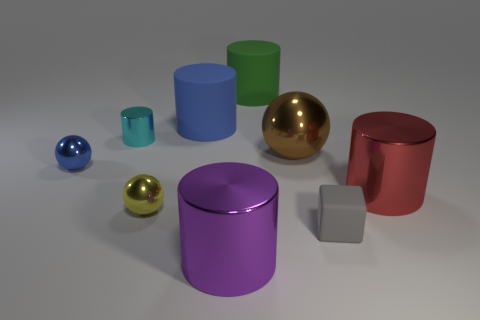Are there any purple cylinders that have the same size as the green object?
Provide a short and direct response. Yes. There is a sphere that is behind the small blue sphere; what size is it?
Your answer should be very brief. Large. There is a tiny object on the right side of the yellow shiny thing; are there any brown things that are behind it?
Your response must be concise. Yes. What number of other objects are there of the same shape as the purple object?
Make the answer very short. 4. Is the shape of the red object the same as the green object?
Your response must be concise. Yes. The small thing that is on the left side of the purple cylinder and in front of the blue shiny thing is what color?
Ensure brevity in your answer.  Yellow. How many big objects are brown objects or green cylinders?
Provide a succinct answer. 2. Are there any other things that are the same color as the large shiny sphere?
Your answer should be compact. No. There is a sphere in front of the small thing that is to the left of the metallic cylinder that is to the left of the purple metal thing; what is it made of?
Ensure brevity in your answer.  Metal. What number of metal things are small purple spheres or yellow objects?
Give a very brief answer. 1. 